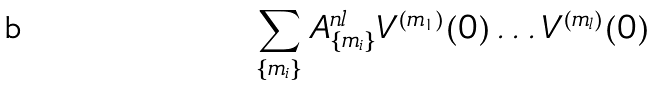Convert formula to latex. <formula><loc_0><loc_0><loc_500><loc_500>\sum _ { \{ m _ { i } \} } A _ { \{ m _ { i } \} } ^ { n l } V ^ { ( m _ { 1 } ) } ( 0 ) \dots V ^ { ( m _ { l } ) } ( 0 )</formula> 